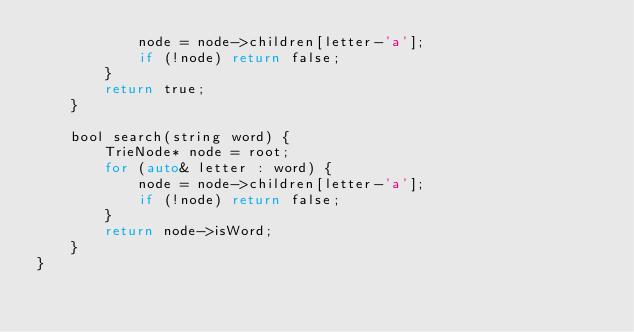<code> <loc_0><loc_0><loc_500><loc_500><_C_>            node = node->children[letter-'a']; 
            if (!node) return false; 
        }
        return true; 
    }

    bool search(string word) {
        TrieNode* node = root; 
        for (auto& letter : word) {
            node = node->children[letter-'a']; 
            if (!node) return false; 
        }
        return node->isWord; 
    }
}</code> 